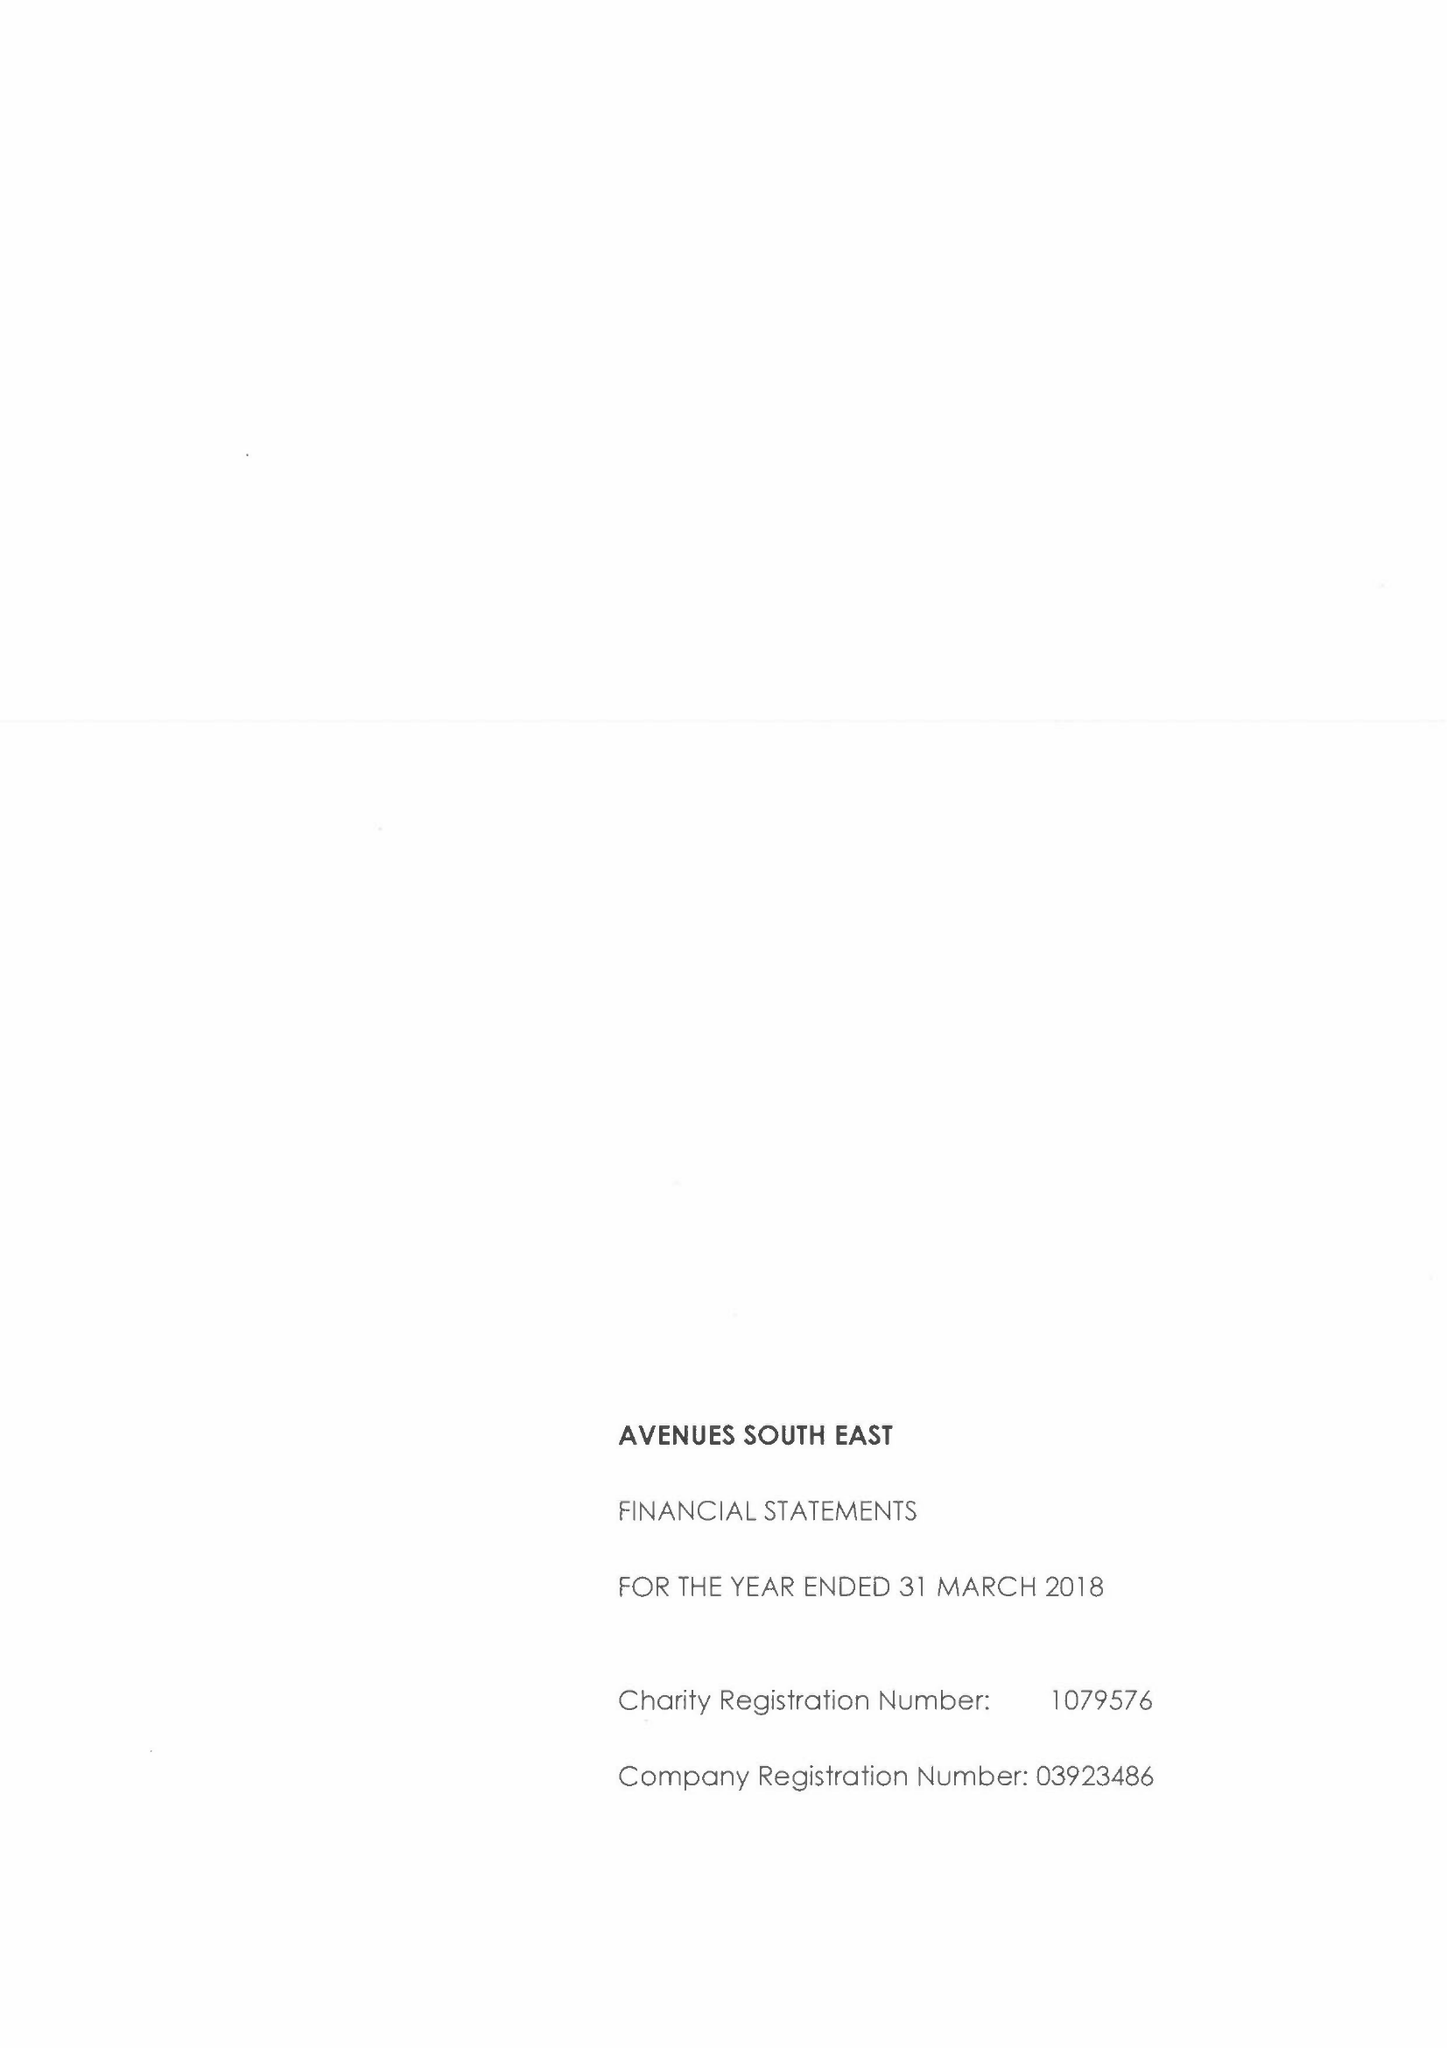What is the value for the address__postcode?
Answer the question using a single word or phrase. DA14 5TA 